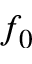<formula> <loc_0><loc_0><loc_500><loc_500>f _ { 0 }</formula> 